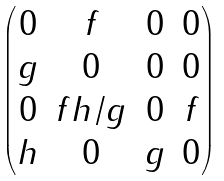<formula> <loc_0><loc_0><loc_500><loc_500>\begin{pmatrix} 0 & f & 0 & 0 \\ g & 0 & 0 & 0 \\ 0 & f h / g & 0 & f \\ h & 0 & g & 0 \end{pmatrix}</formula> 